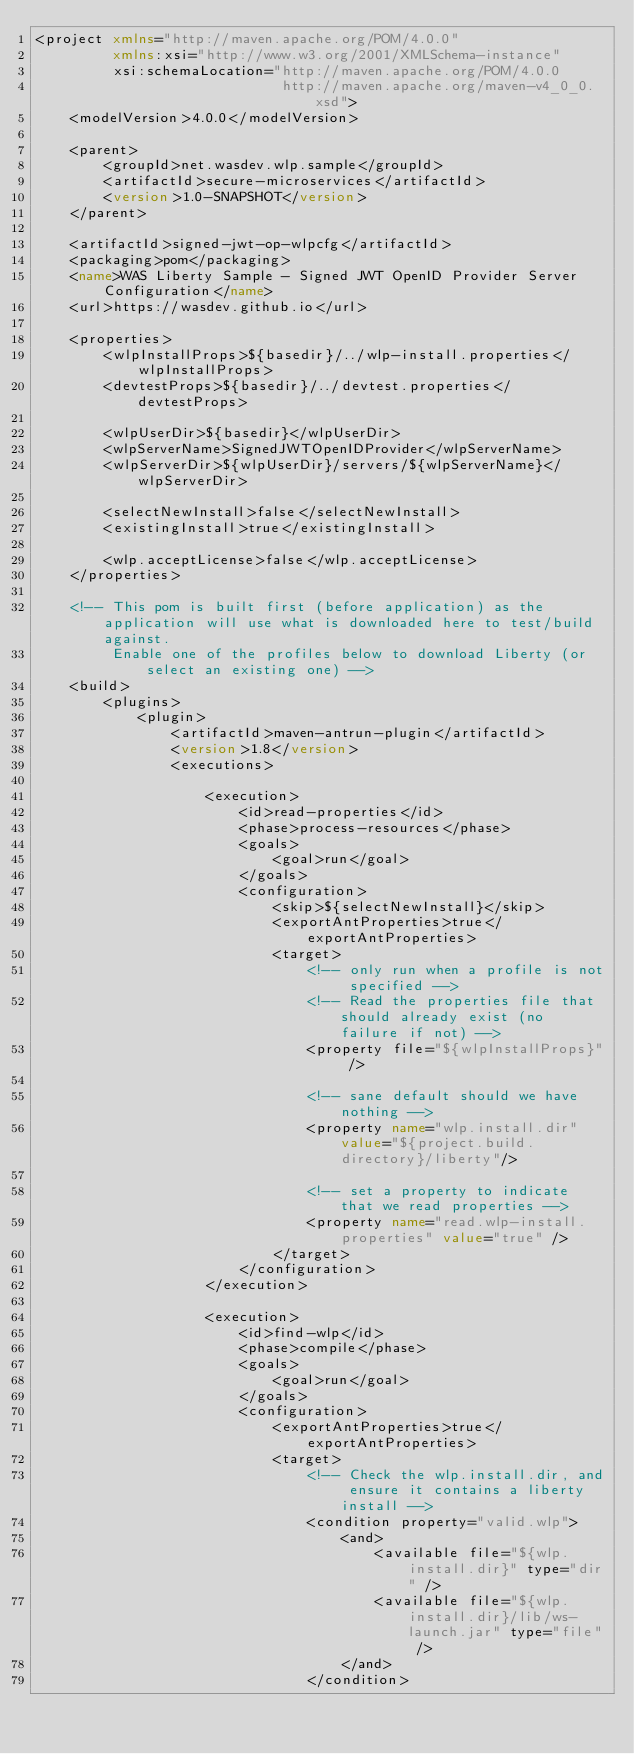<code> <loc_0><loc_0><loc_500><loc_500><_XML_><project xmlns="http://maven.apache.org/POM/4.0.0"
         xmlns:xsi="http://www.w3.org/2001/XMLSchema-instance"
         xsi:schemaLocation="http://maven.apache.org/POM/4.0.0
                             http://maven.apache.org/maven-v4_0_0.xsd">
    <modelVersion>4.0.0</modelVersion>

    <parent>
    	<groupId>net.wasdev.wlp.sample</groupId>
    	<artifactId>secure-microservices</artifactId>
    	<version>1.0-SNAPSHOT</version>
    </parent>

    <artifactId>signed-jwt-op-wlpcfg</artifactId>
    <packaging>pom</packaging>
    <name>WAS Liberty Sample - Signed JWT OpenID Provider Server Configuration</name>
    <url>https://wasdev.github.io</url>

    <properties>
        <wlpInstallProps>${basedir}/../wlp-install.properties</wlpInstallProps>
        <devtestProps>${basedir}/../devtest.properties</devtestProps>

        <wlpUserDir>${basedir}</wlpUserDir>
        <wlpServerName>SignedJWTOpenIDProvider</wlpServerName>
        <wlpServerDir>${wlpUserDir}/servers/${wlpServerName}</wlpServerDir>

        <selectNewInstall>false</selectNewInstall>
        <existingInstall>true</existingInstall>

        <wlp.acceptLicense>false</wlp.acceptLicense>
    </properties>

    <!-- This pom is built first (before application) as the application will use what is downloaded here to test/build against.
         Enable one of the profiles below to download Liberty (or select an existing one) -->
    <build>
    	<plugins>
            <plugin>
                <artifactId>maven-antrun-plugin</artifactId>
                <version>1.8</version>
                <executions>

                    <execution>
                        <id>read-properties</id>
                        <phase>process-resources</phase>
                        <goals>
                            <goal>run</goal>
                        </goals>
                        <configuration>
                            <skip>${selectNewInstall}</skip>
                            <exportAntProperties>true</exportAntProperties>
                            <target>
                                <!-- only run when a profile is not specified -->
                                <!-- Read the properties file that should already exist (no failure if not) -->
                                <property file="${wlpInstallProps}" />

                                <!-- sane default should we have nothing -->
                                <property name="wlp.install.dir" value="${project.build.directory}/liberty"/>

                                <!-- set a property to indicate that we read properties -->
                                <property name="read.wlp-install.properties" value="true" />
                            </target>
                        </configuration>
                    </execution>

                    <execution>
                        <id>find-wlp</id>
                        <phase>compile</phase>
                        <goals>
                            <goal>run</goal>
                        </goals>
                        <configuration>
                            <exportAntProperties>true</exportAntProperties>
                            <target>
                                <!-- Check the wlp.install.dir, and ensure it contains a liberty install -->
                                <condition property="valid.wlp">
                                    <and>
                                        <available file="${wlp.install.dir}" type="dir" />
                                        <available file="${wlp.install.dir}/lib/ws-launch.jar" type="file" />
                                    </and>
                                </condition>
</code> 